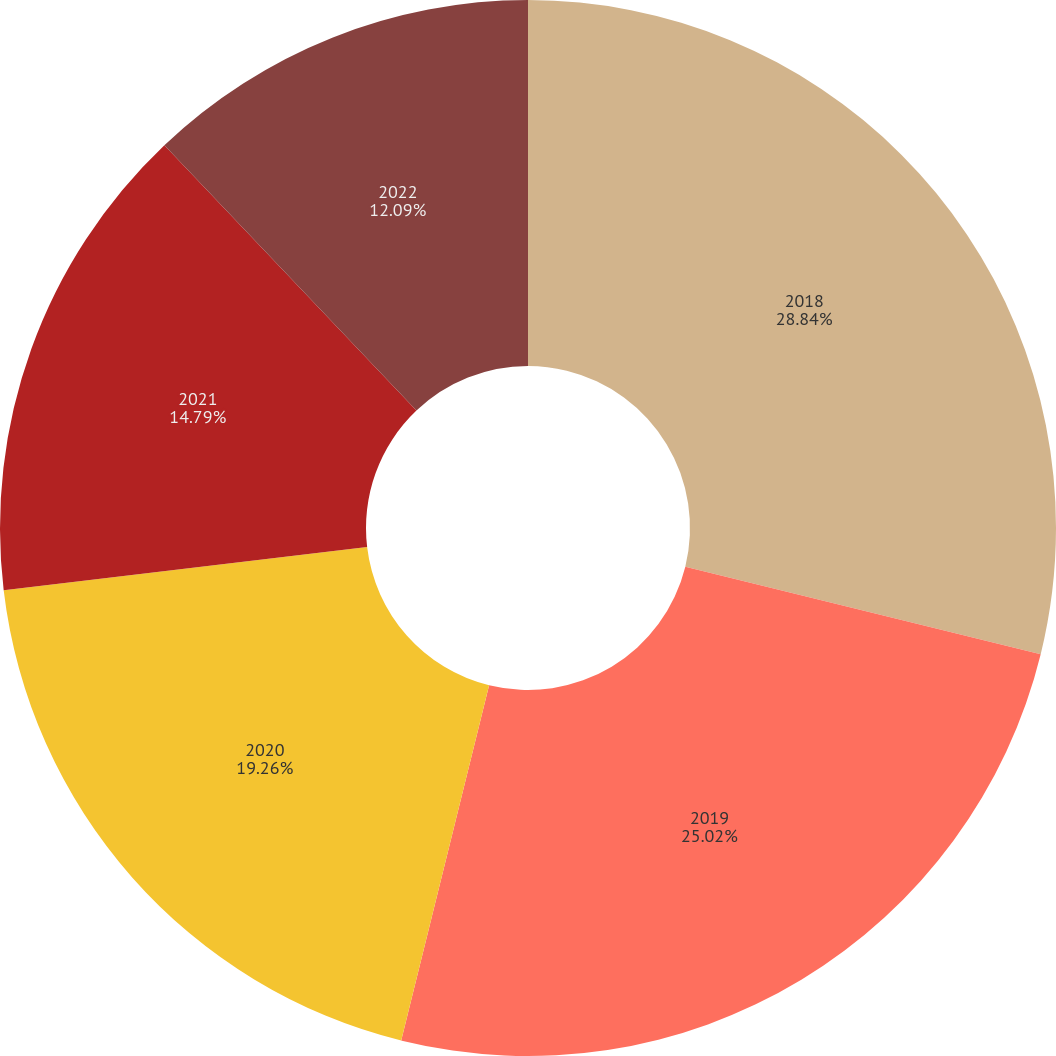Convert chart. <chart><loc_0><loc_0><loc_500><loc_500><pie_chart><fcel>2018<fcel>2019<fcel>2020<fcel>2021<fcel>2022<nl><fcel>28.84%<fcel>25.02%<fcel>19.26%<fcel>14.79%<fcel>12.09%<nl></chart> 